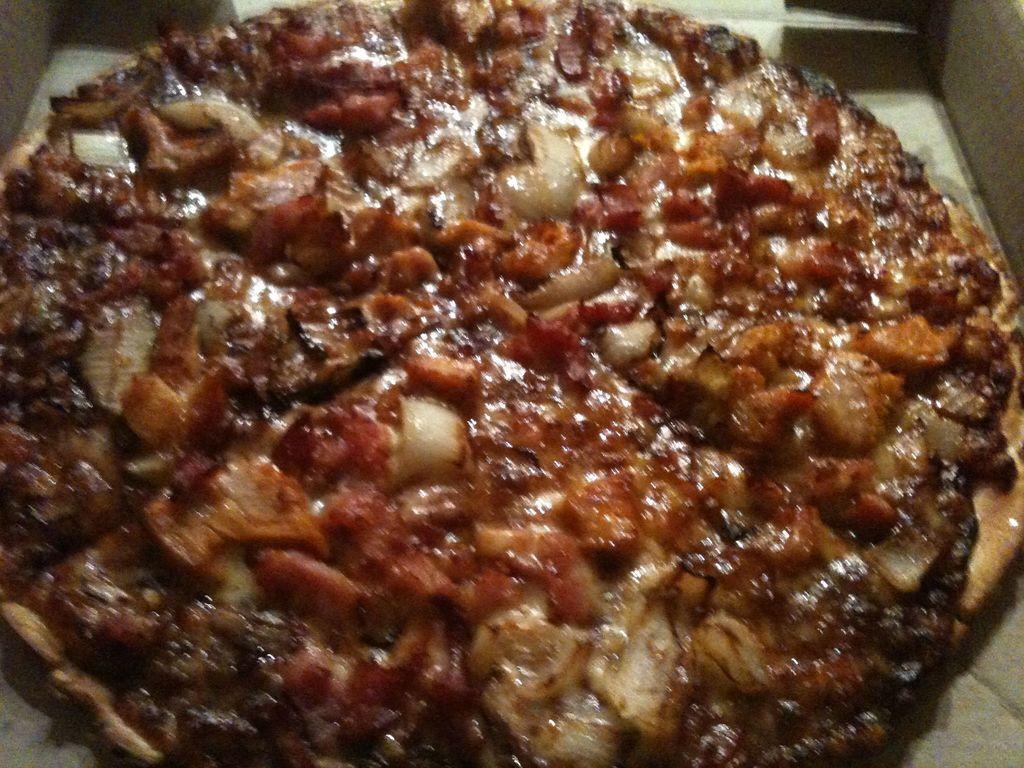In one or two sentences, can you explain what this image depicts? In this image we can see a pizza with veggies. 